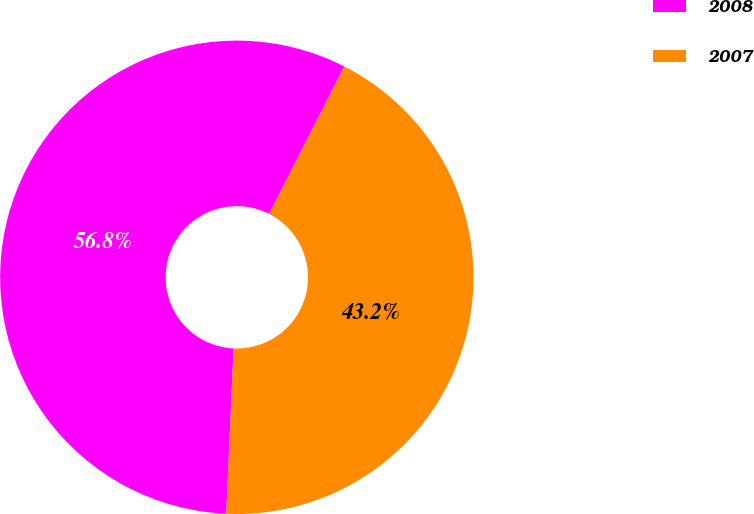<chart> <loc_0><loc_0><loc_500><loc_500><pie_chart><fcel>2008<fcel>2007<nl><fcel>56.79%<fcel>43.21%<nl></chart> 